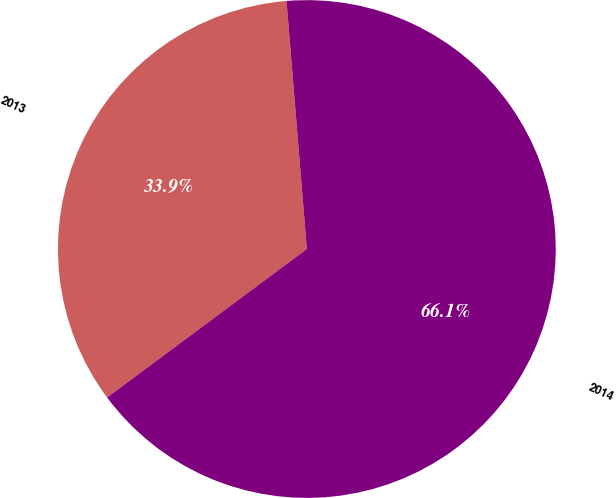Convert chart to OTSL. <chart><loc_0><loc_0><loc_500><loc_500><pie_chart><fcel>2013<fcel>2014<nl><fcel>33.87%<fcel>66.13%<nl></chart> 